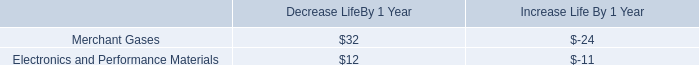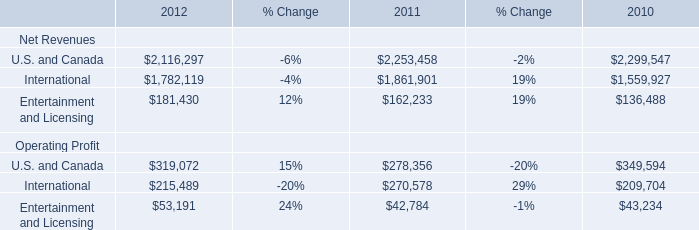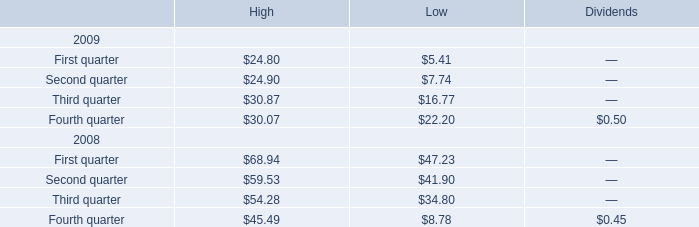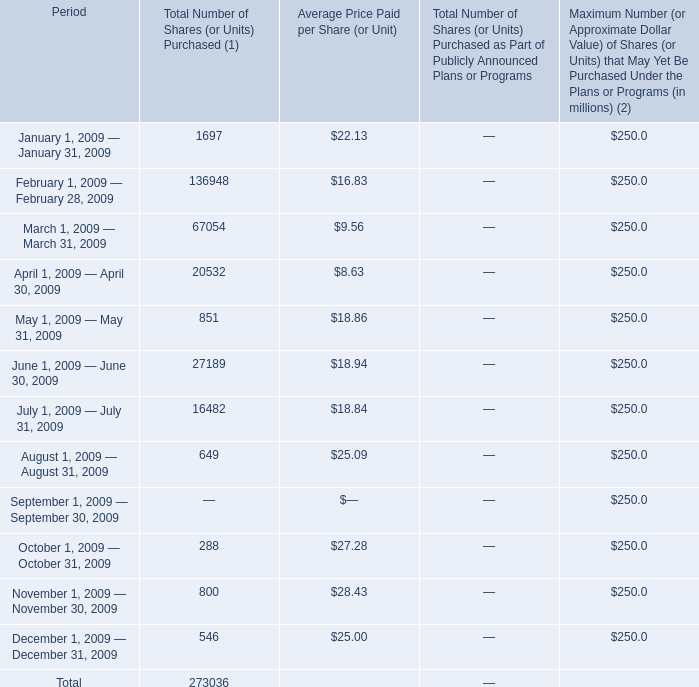considering the contract terms of 15 years , what will be the total expense with the depreciation of the merchant gases segment?\\n 
Computations: (24 * 15)
Answer: 360.0. 